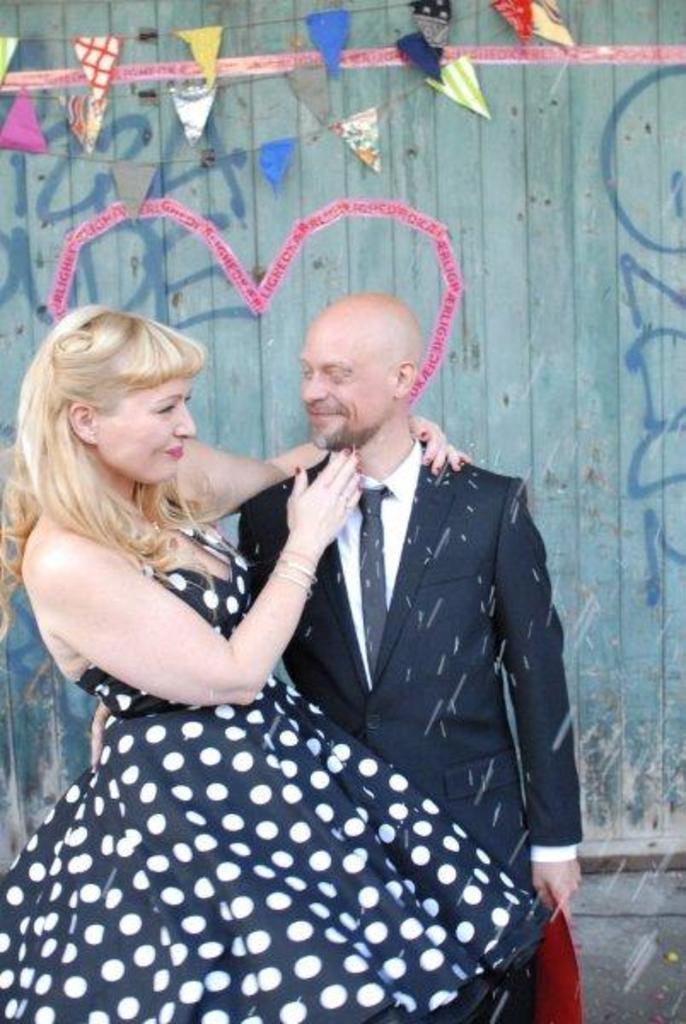Who can be seen in the image? There is a man and a lady in the image. What are the man and the lady doing in the image? Both the man and the lady are standing and smiling. What can be seen in the background of the image? There is a wall in the background of the image. What is on the wall in the image? Decors are placed on the wall, and there is graffiti on the wall. Can you tell me how many yaks are visible on the roof in the image? There are no yaks or roofs present in the image; it features a man, a lady, and a wall with decorations and graffiti. What type of hands are holding the graffiti on the wall? There is no indication of hands holding the graffiti in the image; it is simply present on the wall. 